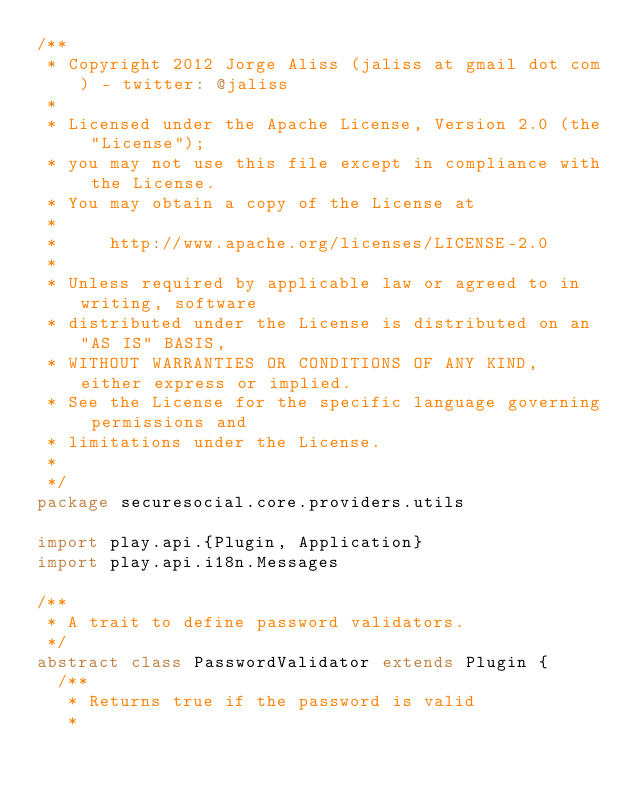<code> <loc_0><loc_0><loc_500><loc_500><_Scala_>/**
 * Copyright 2012 Jorge Aliss (jaliss at gmail dot com) - twitter: @jaliss
 *
 * Licensed under the Apache License, Version 2.0 (the "License");
 * you may not use this file except in compliance with the License.
 * You may obtain a copy of the License at
 *
 *     http://www.apache.org/licenses/LICENSE-2.0
 *
 * Unless required by applicable law or agreed to in writing, software
 * distributed under the License is distributed on an "AS IS" BASIS,
 * WITHOUT WARRANTIES OR CONDITIONS OF ANY KIND, either express or implied.
 * See the License for the specific language governing permissions and
 * limitations under the License.
 *
 */
package securesocial.core.providers.utils

import play.api.{Plugin, Application}
import play.api.i18n.Messages

/**
 * A trait to define password validators.
 */
abstract class PasswordValidator extends Plugin {
  /**
   * Returns true if the password is valid
   *</code> 